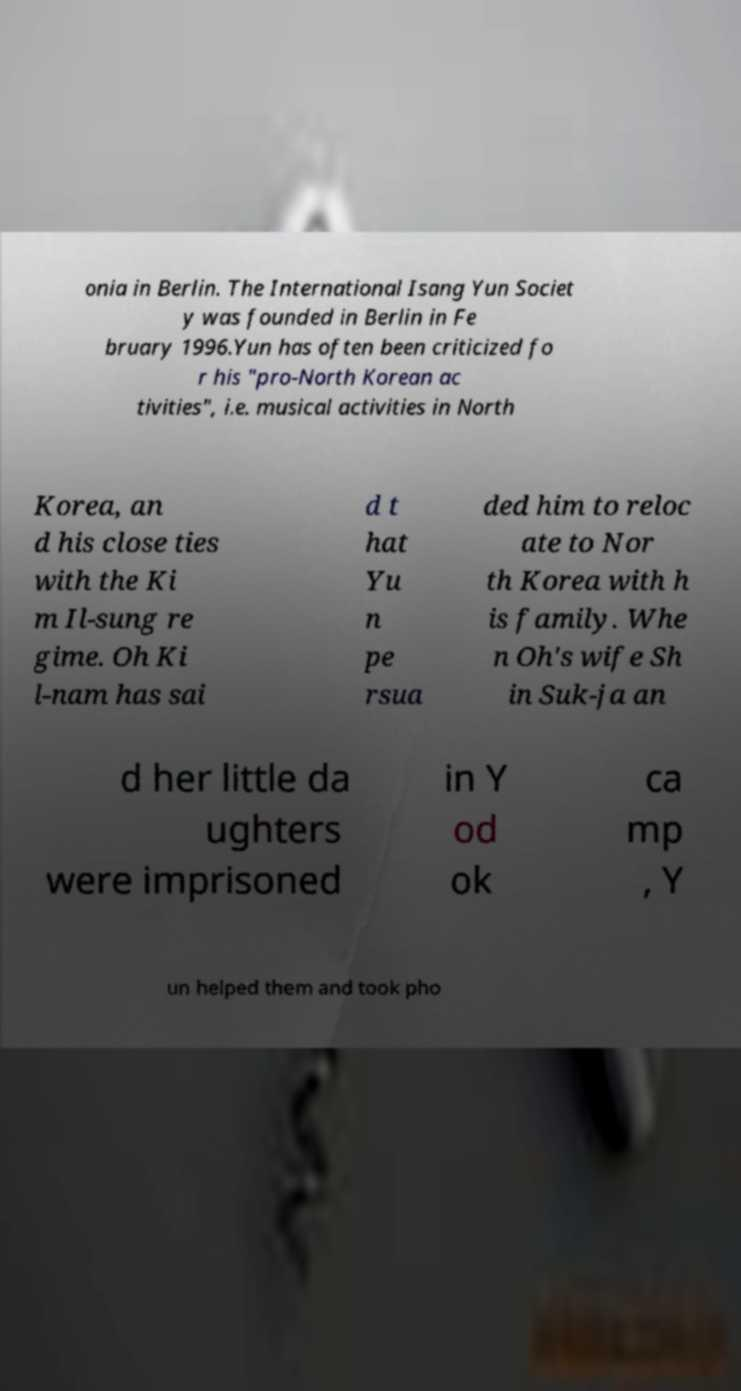What messages or text are displayed in this image? I need them in a readable, typed format. onia in Berlin. The International Isang Yun Societ y was founded in Berlin in Fe bruary 1996.Yun has often been criticized fo r his "pro-North Korean ac tivities", i.e. musical activities in North Korea, an d his close ties with the Ki m Il-sung re gime. Oh Ki l-nam has sai d t hat Yu n pe rsua ded him to reloc ate to Nor th Korea with h is family. Whe n Oh's wife Sh in Suk-ja an d her little da ughters were imprisoned in Y od ok ca mp , Y un helped them and took pho 